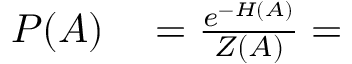<formula> <loc_0><loc_0><loc_500><loc_500>\begin{array} { r l } { P ( A ) } & = \frac { e ^ { - H ( A ) } } { Z ( A ) } = } \end{array}</formula> 